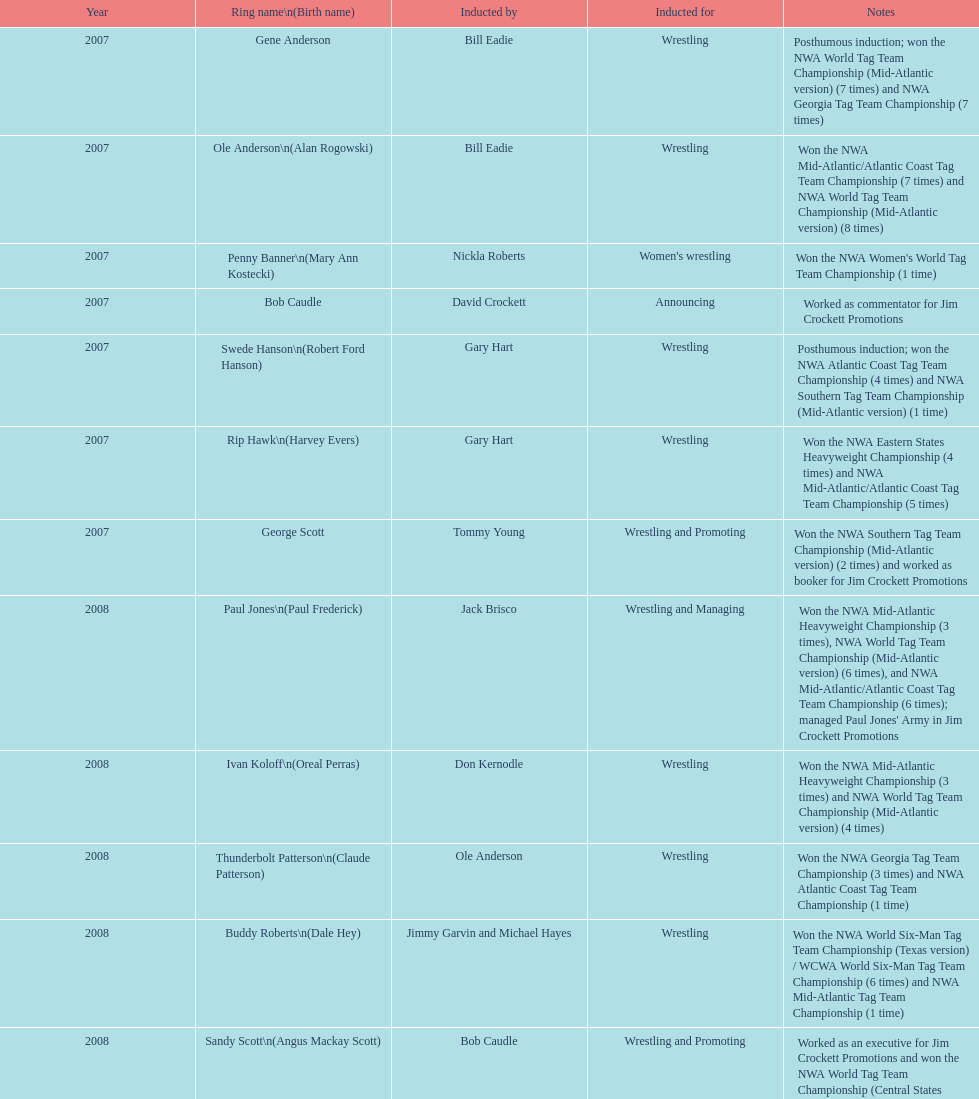Who won the most nwa southern tag team championships (mid-america version)? Jackie Fargo. Write the full table. {'header': ['Year', 'Ring name\\n(Birth name)', 'Inducted by', 'Inducted for', 'Notes'], 'rows': [['2007', 'Gene Anderson', 'Bill Eadie', 'Wrestling', 'Posthumous induction; won the NWA World Tag Team Championship (Mid-Atlantic version) (7 times) and NWA Georgia Tag Team Championship (7 times)'], ['2007', 'Ole Anderson\\n(Alan Rogowski)', 'Bill Eadie', 'Wrestling', 'Won the NWA Mid-Atlantic/Atlantic Coast Tag Team Championship (7 times) and NWA World Tag Team Championship (Mid-Atlantic version) (8 times)'], ['2007', 'Penny Banner\\n(Mary Ann Kostecki)', 'Nickla Roberts', "Women's wrestling", "Won the NWA Women's World Tag Team Championship (1 time)"], ['2007', 'Bob Caudle', 'David Crockett', 'Announcing', 'Worked as commentator for Jim Crockett Promotions'], ['2007', 'Swede Hanson\\n(Robert Ford Hanson)', 'Gary Hart', 'Wrestling', 'Posthumous induction; won the NWA Atlantic Coast Tag Team Championship (4 times) and NWA Southern Tag Team Championship (Mid-Atlantic version) (1 time)'], ['2007', 'Rip Hawk\\n(Harvey Evers)', 'Gary Hart', 'Wrestling', 'Won the NWA Eastern States Heavyweight Championship (4 times) and NWA Mid-Atlantic/Atlantic Coast Tag Team Championship (5 times)'], ['2007', 'George Scott', 'Tommy Young', 'Wrestling and Promoting', 'Won the NWA Southern Tag Team Championship (Mid-Atlantic version) (2 times) and worked as booker for Jim Crockett Promotions'], ['2008', 'Paul Jones\\n(Paul Frederick)', 'Jack Brisco', 'Wrestling and Managing', "Won the NWA Mid-Atlantic Heavyweight Championship (3 times), NWA World Tag Team Championship (Mid-Atlantic version) (6 times), and NWA Mid-Atlantic/Atlantic Coast Tag Team Championship (6 times); managed Paul Jones' Army in Jim Crockett Promotions"], ['2008', 'Ivan Koloff\\n(Oreal Perras)', 'Don Kernodle', 'Wrestling', 'Won the NWA Mid-Atlantic Heavyweight Championship (3 times) and NWA World Tag Team Championship (Mid-Atlantic version) (4 times)'], ['2008', 'Thunderbolt Patterson\\n(Claude Patterson)', 'Ole Anderson', 'Wrestling', 'Won the NWA Georgia Tag Team Championship (3 times) and NWA Atlantic Coast Tag Team Championship (1 time)'], ['2008', 'Buddy Roberts\\n(Dale Hey)', 'Jimmy Garvin and Michael Hayes', 'Wrestling', 'Won the NWA World Six-Man Tag Team Championship (Texas version) / WCWA World Six-Man Tag Team Championship (6 times) and NWA Mid-Atlantic Tag Team Championship (1 time)'], ['2008', 'Sandy Scott\\n(Angus Mackay Scott)', 'Bob Caudle', 'Wrestling and Promoting', 'Worked as an executive for Jim Crockett Promotions and won the NWA World Tag Team Championship (Central States version) (1 time) and NWA Southern Tag Team Championship (Mid-Atlantic version) (3 times)'], ['2008', 'Grizzly Smith\\n(Aurelian Smith)', 'Magnum T.A.', 'Wrestling', 'Won the NWA United States Tag Team Championship (Tri-State version) (2 times) and NWA Texas Heavyweight Championship (1 time)'], ['2008', 'Johnny Weaver\\n(Kenneth Eugene Weaver)', 'Rip Hawk', 'Wrestling', 'Posthumous induction; won the NWA Atlantic Coast/Mid-Atlantic Tag Team Championship (8 times) and NWA Southern Tag Team Championship (Mid-Atlantic version) (6 times)'], ['2009', 'Don Fargo\\n(Don Kalt)', 'Jerry Jarrett & Steve Keirn', 'Wrestling', 'Won the NWA Southern Tag Team Championship (Mid-America version) (2 times) and NWA World Tag Team Championship (Mid-America version) (6 times)'], ['2009', 'Jackie Fargo\\n(Henry Faggart)', 'Jerry Jarrett & Steve Keirn', 'Wrestling', 'Won the NWA World Tag Team Championship (Mid-America version) (10 times) and NWA Southern Tag Team Championship (Mid-America version) (22 times)'], ['2009', 'Sonny Fargo\\n(Jack Lewis Faggart)', 'Jerry Jarrett & Steve Keirn', 'Wrestling', 'Posthumous induction; won the NWA Southern Tag Team Championship (Mid-America version) (3 times)'], ['2009', 'Gary Hart\\n(Gary Williams)', 'Sir Oliver Humperdink', 'Managing and Promoting', 'Posthumous induction; worked as a booker in World Class Championship Wrestling and managed several wrestlers in Mid-Atlantic Championship Wrestling'], ['2009', 'Wahoo McDaniel\\n(Edward McDaniel)', 'Tully Blanchard', 'Wrestling', 'Posthumous induction; won the NWA Mid-Atlantic Heavyweight Championship (6 times) and NWA World Tag Team Championship (Mid-Atlantic version) (4 times)'], ['2009', 'Blackjack Mulligan\\n(Robert Windham)', 'Ric Flair', 'Wrestling', 'Won the NWA Texas Heavyweight Championship (1 time) and NWA World Tag Team Championship (Mid-Atlantic version) (1 time)'], ['2009', 'Nelson Royal', 'Brad Anderson, Tommy Angel & David Isley', 'Wrestling', 'Won the NWA Atlantic Coast Tag Team Championship (2 times)'], ['2009', 'Lance Russell', 'Dave Brown', 'Announcing', 'Worked as commentator for wrestling events in the Memphis area']]} 